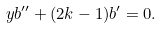Convert formula to latex. <formula><loc_0><loc_0><loc_500><loc_500>y { b ^ { \prime \prime } } + ( 2 k - 1 ) { b ^ { \prime } } = 0 .</formula> 